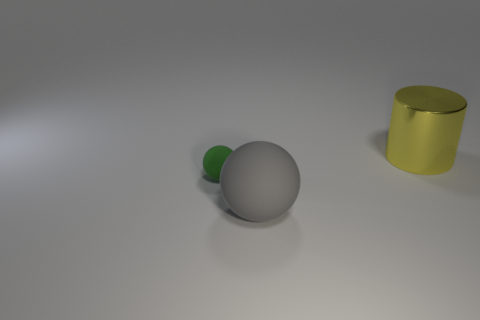What number of big objects are either green rubber balls or metallic things?
Your answer should be very brief. 1. Are there any large gray matte objects that have the same shape as the green rubber object?
Make the answer very short. Yes. Is the gray rubber thing the same shape as the small green matte thing?
Ensure brevity in your answer.  Yes. What is the color of the thing that is behind the rubber sphere that is left of the large rubber ball?
Provide a short and direct response. Yellow. The cylinder that is the same size as the gray rubber thing is what color?
Your response must be concise. Yellow. How many shiny things are large gray spheres or yellow things?
Keep it short and to the point. 1. What number of balls are on the left side of the large object left of the large yellow object?
Offer a terse response. 1. How many things are big gray things or things in front of the yellow metallic thing?
Your response must be concise. 2. Is there a green object that has the same material as the big gray sphere?
Make the answer very short. Yes. What number of objects are behind the tiny green ball and in front of the large yellow shiny object?
Ensure brevity in your answer.  0. 